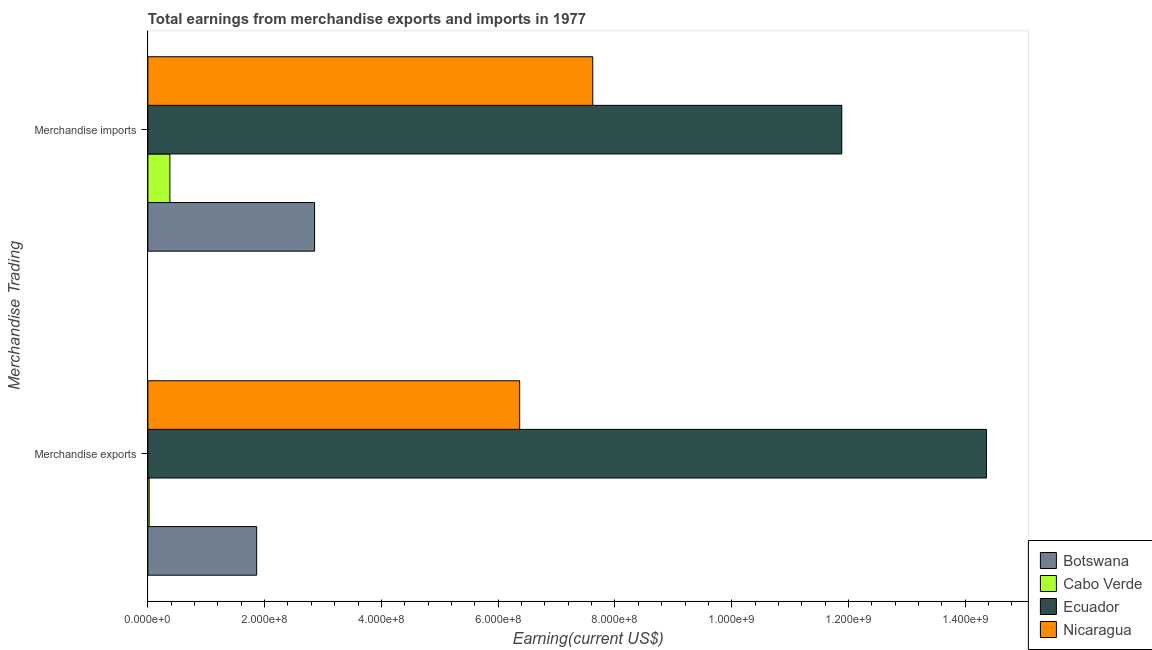How many different coloured bars are there?
Your answer should be compact. 4. Are the number of bars per tick equal to the number of legend labels?
Make the answer very short. Yes. What is the earnings from merchandise imports in Cabo Verde?
Your answer should be compact. 3.77e+07. Across all countries, what is the maximum earnings from merchandise exports?
Offer a very short reply. 1.44e+09. Across all countries, what is the minimum earnings from merchandise exports?
Provide a succinct answer. 2.18e+06. In which country was the earnings from merchandise exports maximum?
Provide a short and direct response. Ecuador. In which country was the earnings from merchandise imports minimum?
Offer a very short reply. Cabo Verde. What is the total earnings from merchandise imports in the graph?
Give a very brief answer. 2.27e+09. What is the difference between the earnings from merchandise exports in Botswana and that in Cabo Verde?
Keep it short and to the point. 1.84e+08. What is the difference between the earnings from merchandise imports in Nicaragua and the earnings from merchandise exports in Ecuador?
Your answer should be compact. -6.74e+08. What is the average earnings from merchandise exports per country?
Provide a short and direct response. 5.65e+08. What is the difference between the earnings from merchandise imports and earnings from merchandise exports in Botswana?
Keep it short and to the point. 9.92e+07. What is the ratio of the earnings from merchandise exports in Nicaragua to that in Cabo Verde?
Give a very brief answer. 292.21. What does the 1st bar from the top in Merchandise imports represents?
Offer a very short reply. Nicaragua. What does the 2nd bar from the bottom in Merchandise imports represents?
Your answer should be compact. Cabo Verde. How many bars are there?
Offer a terse response. 8. How many countries are there in the graph?
Provide a short and direct response. 4. What is the difference between two consecutive major ticks on the X-axis?
Your answer should be very brief. 2.00e+08. Are the values on the major ticks of X-axis written in scientific E-notation?
Provide a succinct answer. Yes. Does the graph contain any zero values?
Provide a succinct answer. No. What is the title of the graph?
Give a very brief answer. Total earnings from merchandise exports and imports in 1977. Does "Palau" appear as one of the legend labels in the graph?
Offer a terse response. No. What is the label or title of the X-axis?
Provide a succinct answer. Earning(current US$). What is the label or title of the Y-axis?
Offer a terse response. Merchandise Trading. What is the Earning(current US$) of Botswana in Merchandise exports?
Provide a short and direct response. 1.86e+08. What is the Earning(current US$) in Cabo Verde in Merchandise exports?
Your response must be concise. 2.18e+06. What is the Earning(current US$) of Ecuador in Merchandise exports?
Give a very brief answer. 1.44e+09. What is the Earning(current US$) of Nicaragua in Merchandise exports?
Offer a terse response. 6.37e+08. What is the Earning(current US$) in Botswana in Merchandise imports?
Make the answer very short. 2.86e+08. What is the Earning(current US$) in Cabo Verde in Merchandise imports?
Make the answer very short. 3.77e+07. What is the Earning(current US$) in Ecuador in Merchandise imports?
Provide a short and direct response. 1.19e+09. What is the Earning(current US$) of Nicaragua in Merchandise imports?
Your response must be concise. 7.62e+08. Across all Merchandise Trading, what is the maximum Earning(current US$) in Botswana?
Your answer should be very brief. 2.86e+08. Across all Merchandise Trading, what is the maximum Earning(current US$) in Cabo Verde?
Keep it short and to the point. 3.77e+07. Across all Merchandise Trading, what is the maximum Earning(current US$) in Ecuador?
Provide a short and direct response. 1.44e+09. Across all Merchandise Trading, what is the maximum Earning(current US$) in Nicaragua?
Offer a very short reply. 7.62e+08. Across all Merchandise Trading, what is the minimum Earning(current US$) in Botswana?
Give a very brief answer. 1.86e+08. Across all Merchandise Trading, what is the minimum Earning(current US$) of Cabo Verde?
Provide a succinct answer. 2.18e+06. Across all Merchandise Trading, what is the minimum Earning(current US$) of Ecuador?
Provide a succinct answer. 1.19e+09. Across all Merchandise Trading, what is the minimum Earning(current US$) of Nicaragua?
Keep it short and to the point. 6.37e+08. What is the total Earning(current US$) in Botswana in the graph?
Provide a succinct answer. 4.72e+08. What is the total Earning(current US$) in Cabo Verde in the graph?
Your response must be concise. 3.99e+07. What is the total Earning(current US$) of Ecuador in the graph?
Your answer should be very brief. 2.62e+09. What is the total Earning(current US$) of Nicaragua in the graph?
Your answer should be compact. 1.40e+09. What is the difference between the Earning(current US$) in Botswana in Merchandise exports and that in Merchandise imports?
Offer a very short reply. -9.92e+07. What is the difference between the Earning(current US$) of Cabo Verde in Merchandise exports and that in Merchandise imports?
Offer a very short reply. -3.55e+07. What is the difference between the Earning(current US$) of Ecuador in Merchandise exports and that in Merchandise imports?
Your response must be concise. 2.48e+08. What is the difference between the Earning(current US$) of Nicaragua in Merchandise exports and that in Merchandise imports?
Your response must be concise. -1.25e+08. What is the difference between the Earning(current US$) of Botswana in Merchandise exports and the Earning(current US$) of Cabo Verde in Merchandise imports?
Your response must be concise. 1.49e+08. What is the difference between the Earning(current US$) in Botswana in Merchandise exports and the Earning(current US$) in Ecuador in Merchandise imports?
Provide a short and direct response. -1.00e+09. What is the difference between the Earning(current US$) of Botswana in Merchandise exports and the Earning(current US$) of Nicaragua in Merchandise imports?
Provide a succinct answer. -5.76e+08. What is the difference between the Earning(current US$) of Cabo Verde in Merchandise exports and the Earning(current US$) of Ecuador in Merchandise imports?
Keep it short and to the point. -1.19e+09. What is the difference between the Earning(current US$) of Cabo Verde in Merchandise exports and the Earning(current US$) of Nicaragua in Merchandise imports?
Ensure brevity in your answer.  -7.60e+08. What is the difference between the Earning(current US$) in Ecuador in Merchandise exports and the Earning(current US$) in Nicaragua in Merchandise imports?
Provide a short and direct response. 6.74e+08. What is the average Earning(current US$) of Botswana per Merchandise Trading?
Keep it short and to the point. 2.36e+08. What is the average Earning(current US$) in Cabo Verde per Merchandise Trading?
Offer a terse response. 1.99e+07. What is the average Earning(current US$) in Ecuador per Merchandise Trading?
Offer a very short reply. 1.31e+09. What is the average Earning(current US$) in Nicaragua per Merchandise Trading?
Provide a short and direct response. 6.99e+08. What is the difference between the Earning(current US$) in Botswana and Earning(current US$) in Cabo Verde in Merchandise exports?
Your answer should be very brief. 1.84e+08. What is the difference between the Earning(current US$) in Botswana and Earning(current US$) in Ecuador in Merchandise exports?
Keep it short and to the point. -1.25e+09. What is the difference between the Earning(current US$) of Botswana and Earning(current US$) of Nicaragua in Merchandise exports?
Your response must be concise. -4.50e+08. What is the difference between the Earning(current US$) in Cabo Verde and Earning(current US$) in Ecuador in Merchandise exports?
Provide a short and direct response. -1.43e+09. What is the difference between the Earning(current US$) in Cabo Verde and Earning(current US$) in Nicaragua in Merchandise exports?
Your response must be concise. -6.35e+08. What is the difference between the Earning(current US$) in Ecuador and Earning(current US$) in Nicaragua in Merchandise exports?
Keep it short and to the point. 8.00e+08. What is the difference between the Earning(current US$) of Botswana and Earning(current US$) of Cabo Verde in Merchandise imports?
Provide a succinct answer. 2.48e+08. What is the difference between the Earning(current US$) in Botswana and Earning(current US$) in Ecuador in Merchandise imports?
Offer a terse response. -9.03e+08. What is the difference between the Earning(current US$) of Botswana and Earning(current US$) of Nicaragua in Merchandise imports?
Your response must be concise. -4.76e+08. What is the difference between the Earning(current US$) of Cabo Verde and Earning(current US$) of Ecuador in Merchandise imports?
Ensure brevity in your answer.  -1.15e+09. What is the difference between the Earning(current US$) of Cabo Verde and Earning(current US$) of Nicaragua in Merchandise imports?
Offer a very short reply. -7.24e+08. What is the difference between the Earning(current US$) in Ecuador and Earning(current US$) in Nicaragua in Merchandise imports?
Provide a succinct answer. 4.26e+08. What is the ratio of the Earning(current US$) in Botswana in Merchandise exports to that in Merchandise imports?
Your response must be concise. 0.65. What is the ratio of the Earning(current US$) of Cabo Verde in Merchandise exports to that in Merchandise imports?
Keep it short and to the point. 0.06. What is the ratio of the Earning(current US$) of Ecuador in Merchandise exports to that in Merchandise imports?
Provide a succinct answer. 1.21. What is the ratio of the Earning(current US$) in Nicaragua in Merchandise exports to that in Merchandise imports?
Offer a very short reply. 0.84. What is the difference between the highest and the second highest Earning(current US$) of Botswana?
Offer a terse response. 9.92e+07. What is the difference between the highest and the second highest Earning(current US$) in Cabo Verde?
Your answer should be compact. 3.55e+07. What is the difference between the highest and the second highest Earning(current US$) of Ecuador?
Your answer should be very brief. 2.48e+08. What is the difference between the highest and the second highest Earning(current US$) of Nicaragua?
Offer a terse response. 1.25e+08. What is the difference between the highest and the lowest Earning(current US$) in Botswana?
Offer a terse response. 9.92e+07. What is the difference between the highest and the lowest Earning(current US$) of Cabo Verde?
Your response must be concise. 3.55e+07. What is the difference between the highest and the lowest Earning(current US$) of Ecuador?
Provide a succinct answer. 2.48e+08. What is the difference between the highest and the lowest Earning(current US$) of Nicaragua?
Keep it short and to the point. 1.25e+08. 